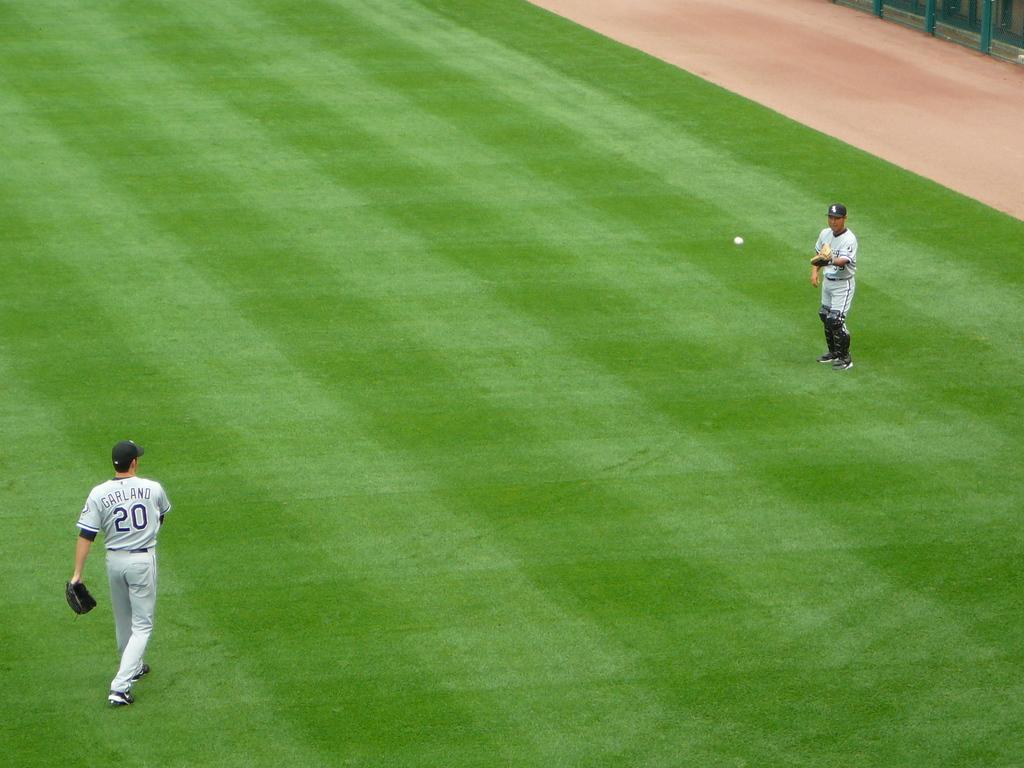Provide a one-sentence caption for the provided image. A baseball player with number 20 throws the ball to another player. 